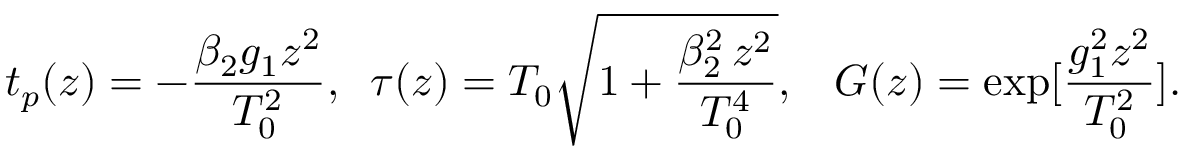Convert formula to latex. <formula><loc_0><loc_0><loc_500><loc_500>t _ { p } ( z ) = - \frac { \beta _ { 2 } g _ { 1 } z ^ { 2 } } { T _ { 0 } ^ { 2 } } , \, \tau ( z ) = T _ { 0 } \sqrt { 1 + \frac { \beta _ { 2 } ^ { 2 } \, z ^ { 2 } } { T _ { 0 } ^ { 4 } } } , \, G ( z ) = \exp [ \frac { g _ { 1 } ^ { 2 } z ^ { 2 } } { T _ { 0 } ^ { 2 } } ] .</formula> 